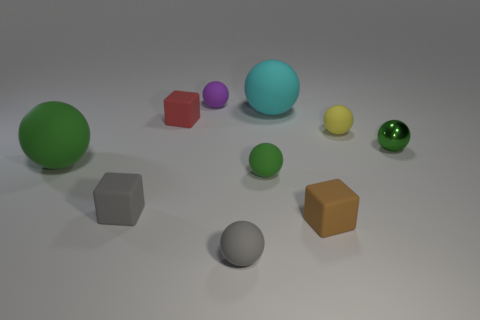Does the big object to the left of the tiny gray block have the same shape as the tiny gray object in front of the brown object?
Give a very brief answer. Yes. What is the color of the small metal ball?
Your answer should be very brief. Green. How many matte things are either tiny gray balls or small brown objects?
Your answer should be very brief. 2. What is the color of the small metallic thing that is the same shape as the large green rubber object?
Give a very brief answer. Green. Are any small blue shiny objects visible?
Keep it short and to the point. No. Does the tiny sphere behind the tiny red matte object have the same material as the yellow thing behind the green shiny thing?
Provide a short and direct response. Yes. What shape is the large matte object that is the same color as the metal sphere?
Your answer should be compact. Sphere. What number of things are either small objects in front of the small gray cube or things to the right of the large cyan rubber sphere?
Make the answer very short. 4. Does the big object that is behind the red matte block have the same color as the rubber cube that is behind the green shiny thing?
Provide a succinct answer. No. What shape is the object that is both to the right of the tiny purple thing and behind the small red matte object?
Keep it short and to the point. Sphere. 